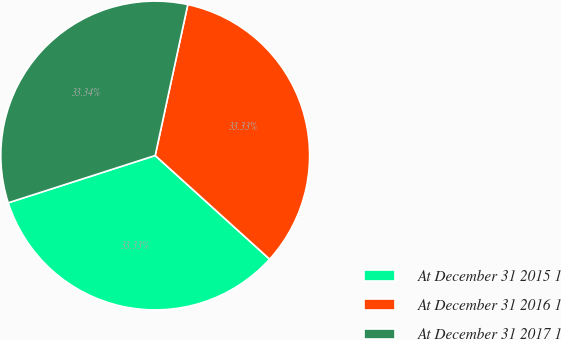Convert chart to OTSL. <chart><loc_0><loc_0><loc_500><loc_500><pie_chart><fcel>At December 31 2015 1<fcel>At December 31 2016 1<fcel>At December 31 2017 1<nl><fcel>33.33%<fcel>33.33%<fcel>33.34%<nl></chart> 